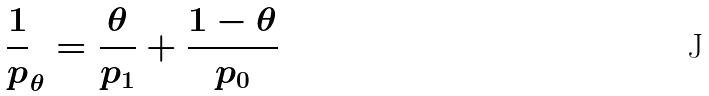<formula> <loc_0><loc_0><loc_500><loc_500>\frac { 1 } { p } _ { \theta } = \frac { \theta } { p _ { 1 } } + \frac { 1 - \theta } { p _ { 0 } }</formula> 